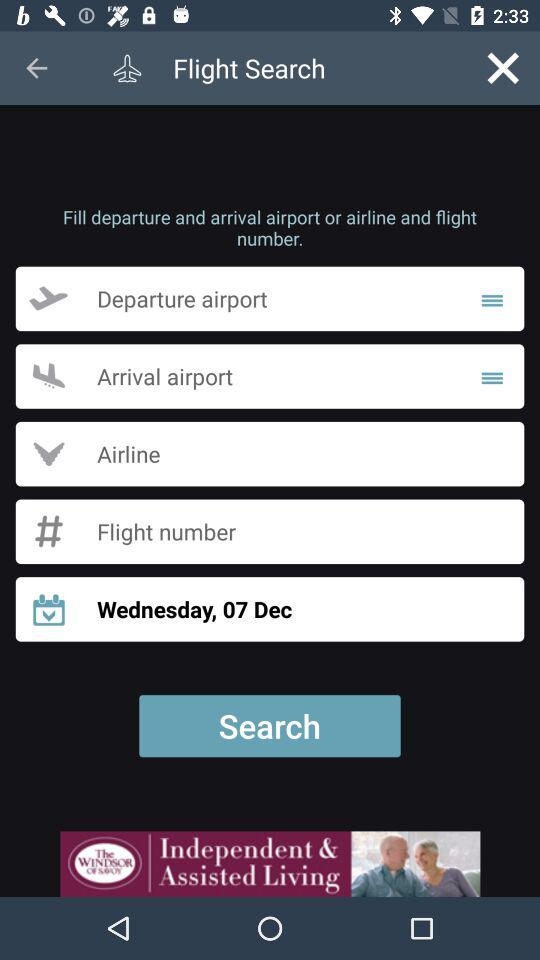For what date are we searching for a flight? The date is Wednesday, December 7. 